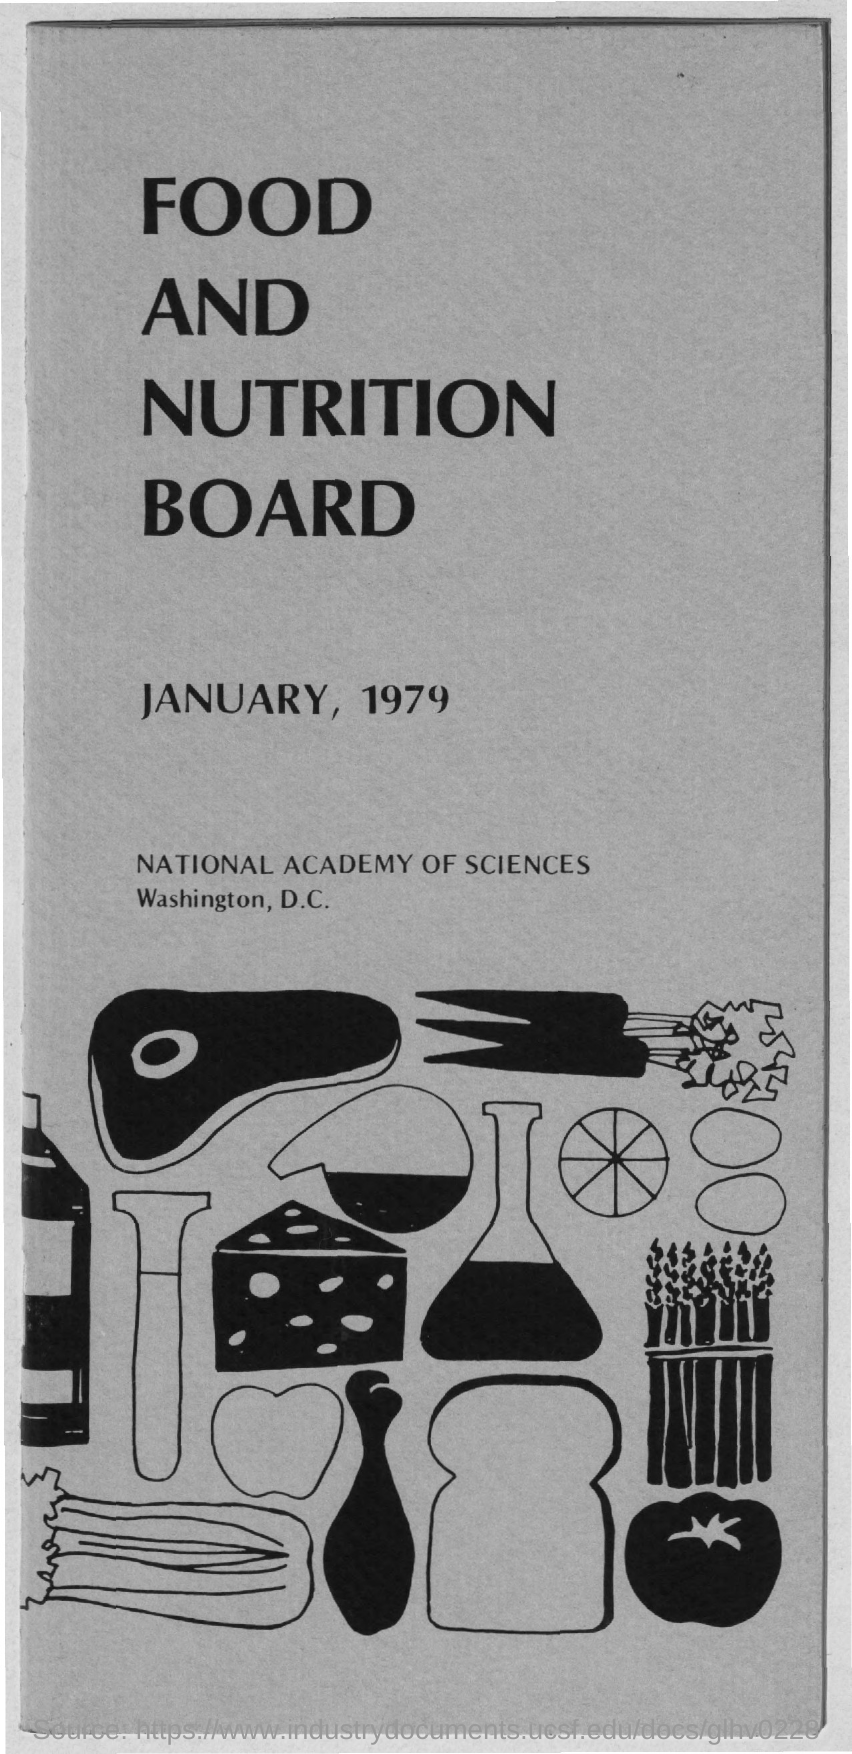Give some essential details in this illustration. The title of the document is "Food and Nutrition Board." The date on the document is January 1979. 